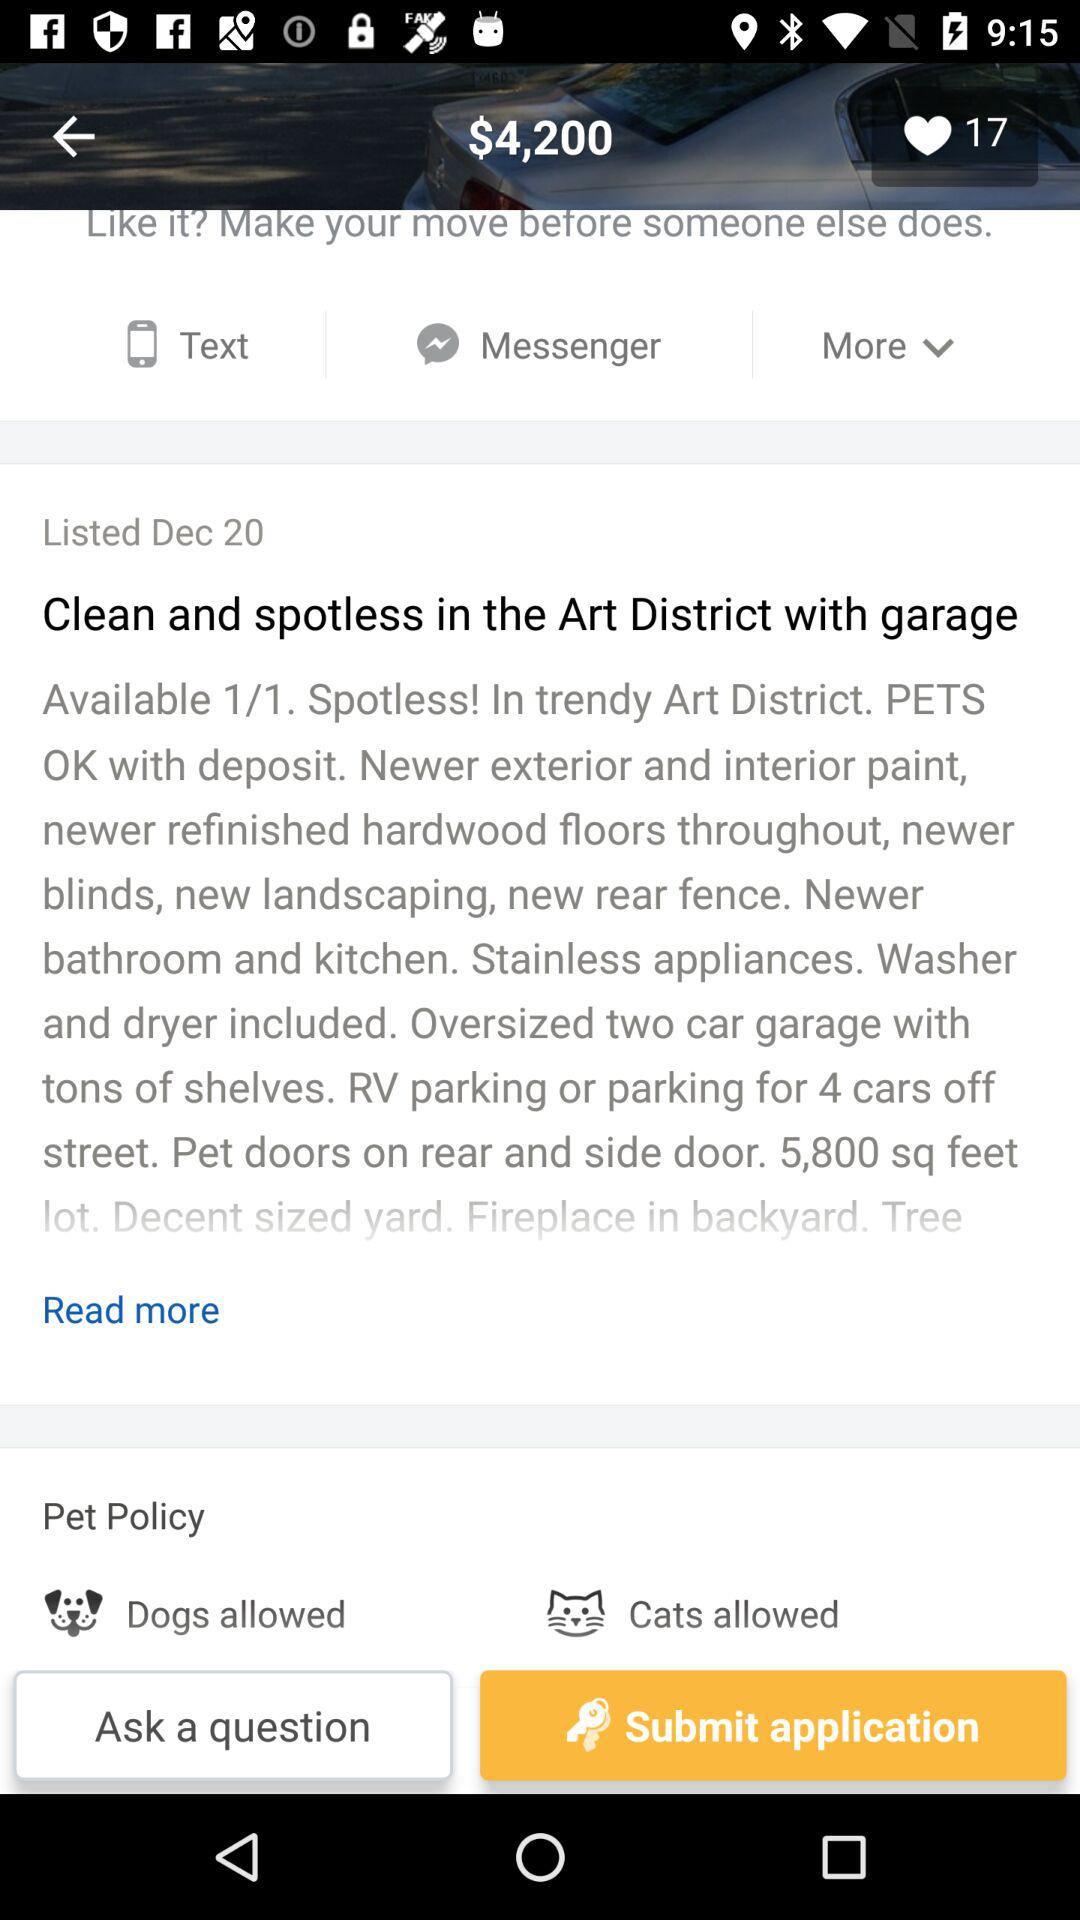How many likes are there? There are 17 likes. 